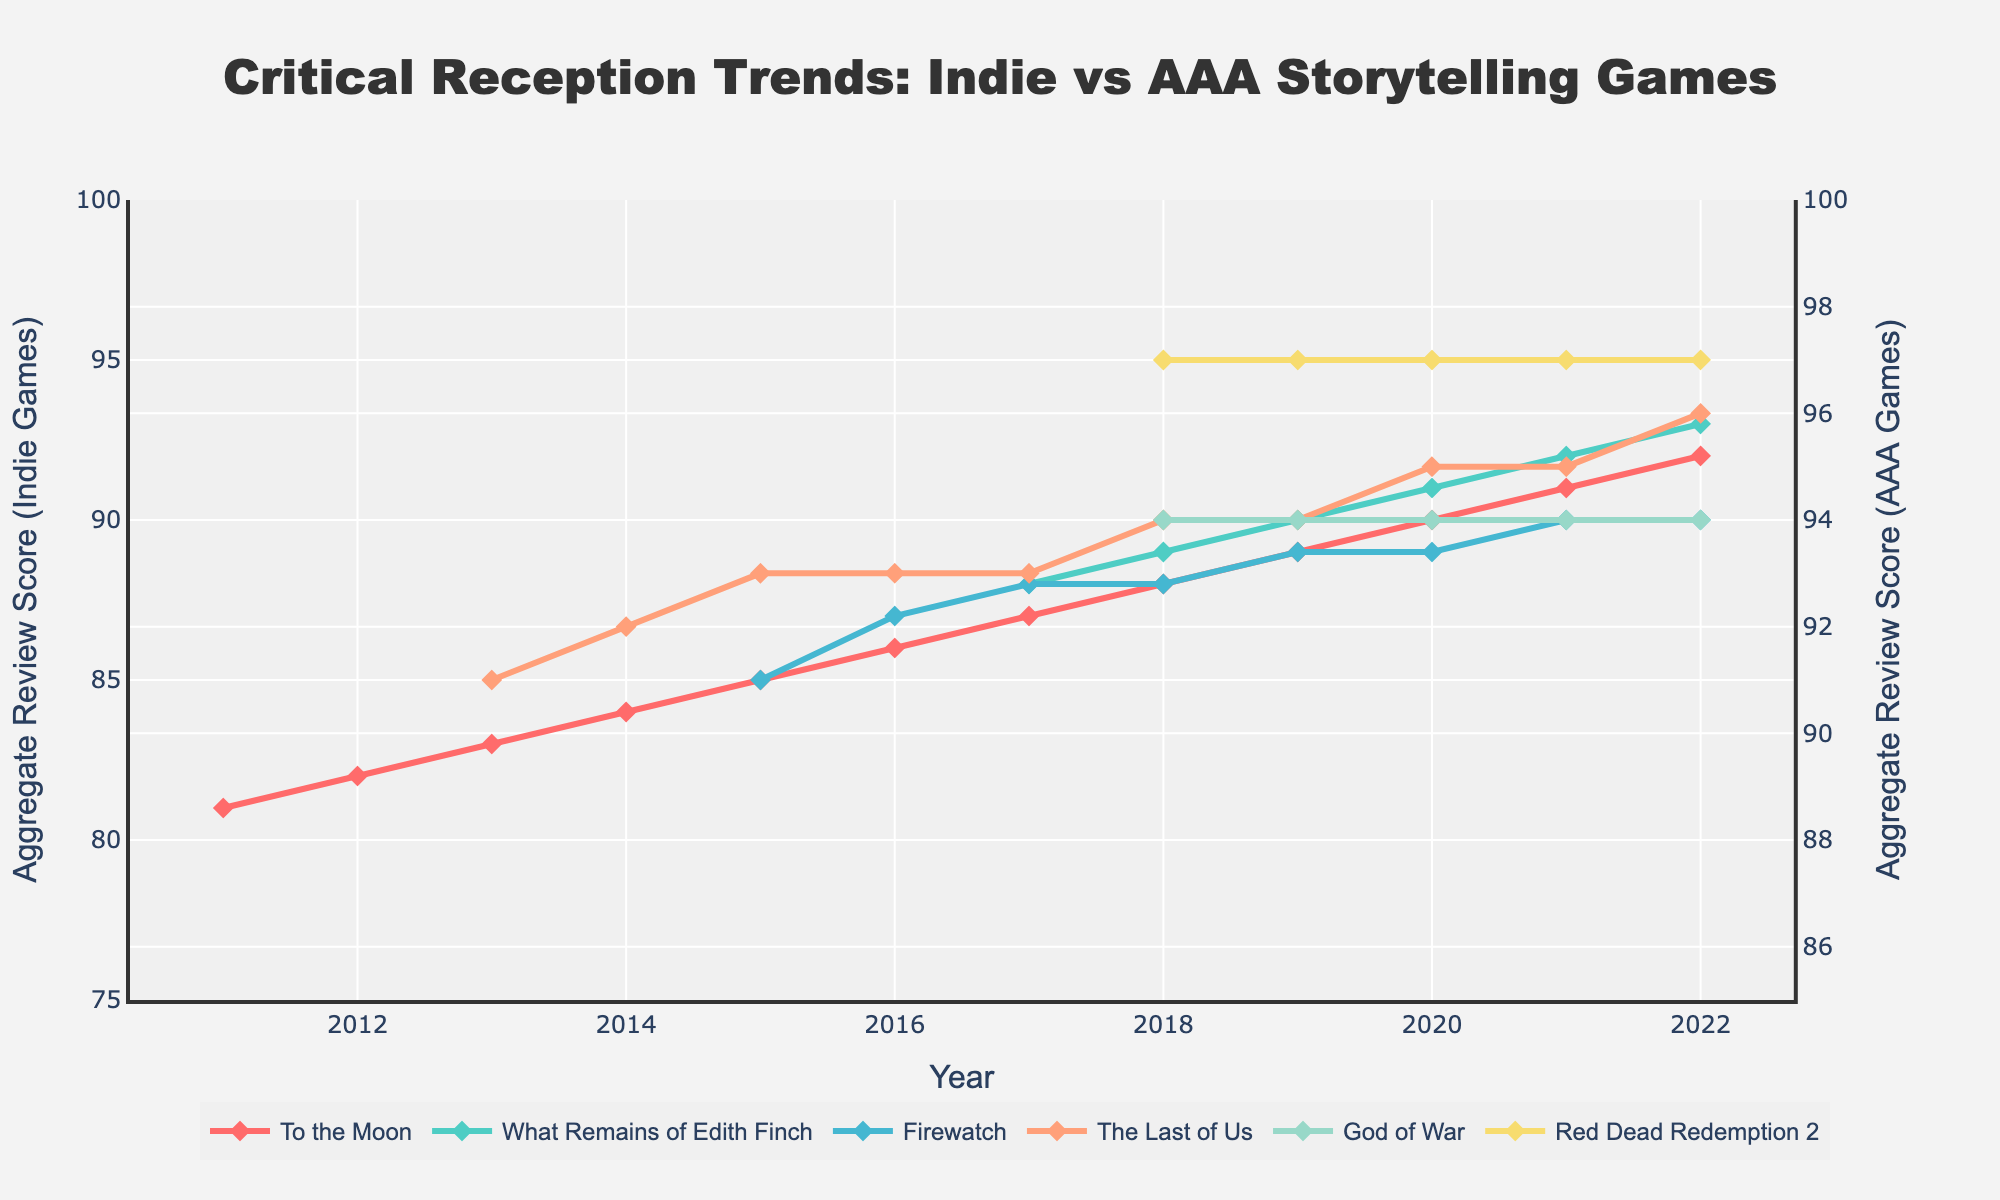Which indie game shows the most consistent increase in aggregate review scores from 2011 to 2022? "To the Moon" shows a consistent yearly increase in aggregate review scores from 2011 (81) to 2022 (92). The data reveals that the scores increased almost every year.
Answer: To the Moon How did "God of War" perform compared to "Red Dead Redemption 2" in 2018? In 2018, "God of War" had an aggregate review score of 94, whereas "Red Dead Redemption 2" had a score of 97. By comparing the two values, we can see that "Red Dead Redemption 2" performed better.
Answer: Red Dead Redemption 2 had a higher score (97 vs 94) In which year did "What Remains of Edith Finch" first receive an aggregate review score? "What Remains of Edith Finch" first appears on the chart in 2017 with an aggregate review score of 88. This is the earliest year listed for this game in the data provided.
Answer: 2017 Compare the average aggregate review scores from 2011 to 2022 for "Firewatch" and "The Last of Us". Which game has a higher average? To find the averages, calculate the sum of the scores for both games and then divide by the number of years they have scores. For "Firewatch": (85+87+88+88+89+89+90+90) / 8 = 88.25. For "The Last of Us": (91+92+93+93+93+94+94+94+95+95+96) / 11 = 93.18. Therefore, "The Last of Us" has a higher average.
Answer: The Last of Us (93.18) Between "To the Moon" and "God of War", which game had a more significant increase in the aggregate review score from their first recorded year to 2022? "To the Moon" increased from 81 in 2011 to 92 in 2022, an increase of 11 points. "God of War" increased from 94 in 2018 to 94 in 2022, which shows no increase. Therefore, "To the Moon" had a more significant increase.
Answer: To the Moon In which year do all listed games have the highest aggregate review scores at the same time? Examining each year for the highest scores of all games, we find that 2022 features the peak scores for "To the Moon" (92), "What Remains of Edith Finch" (93), "Firewatch" (90), "The Last of Us" (96), "God of War" (94), and "Red Dead Redemption 2" (97). This is the only year where all scores are at their highest.
Answer: 2022 